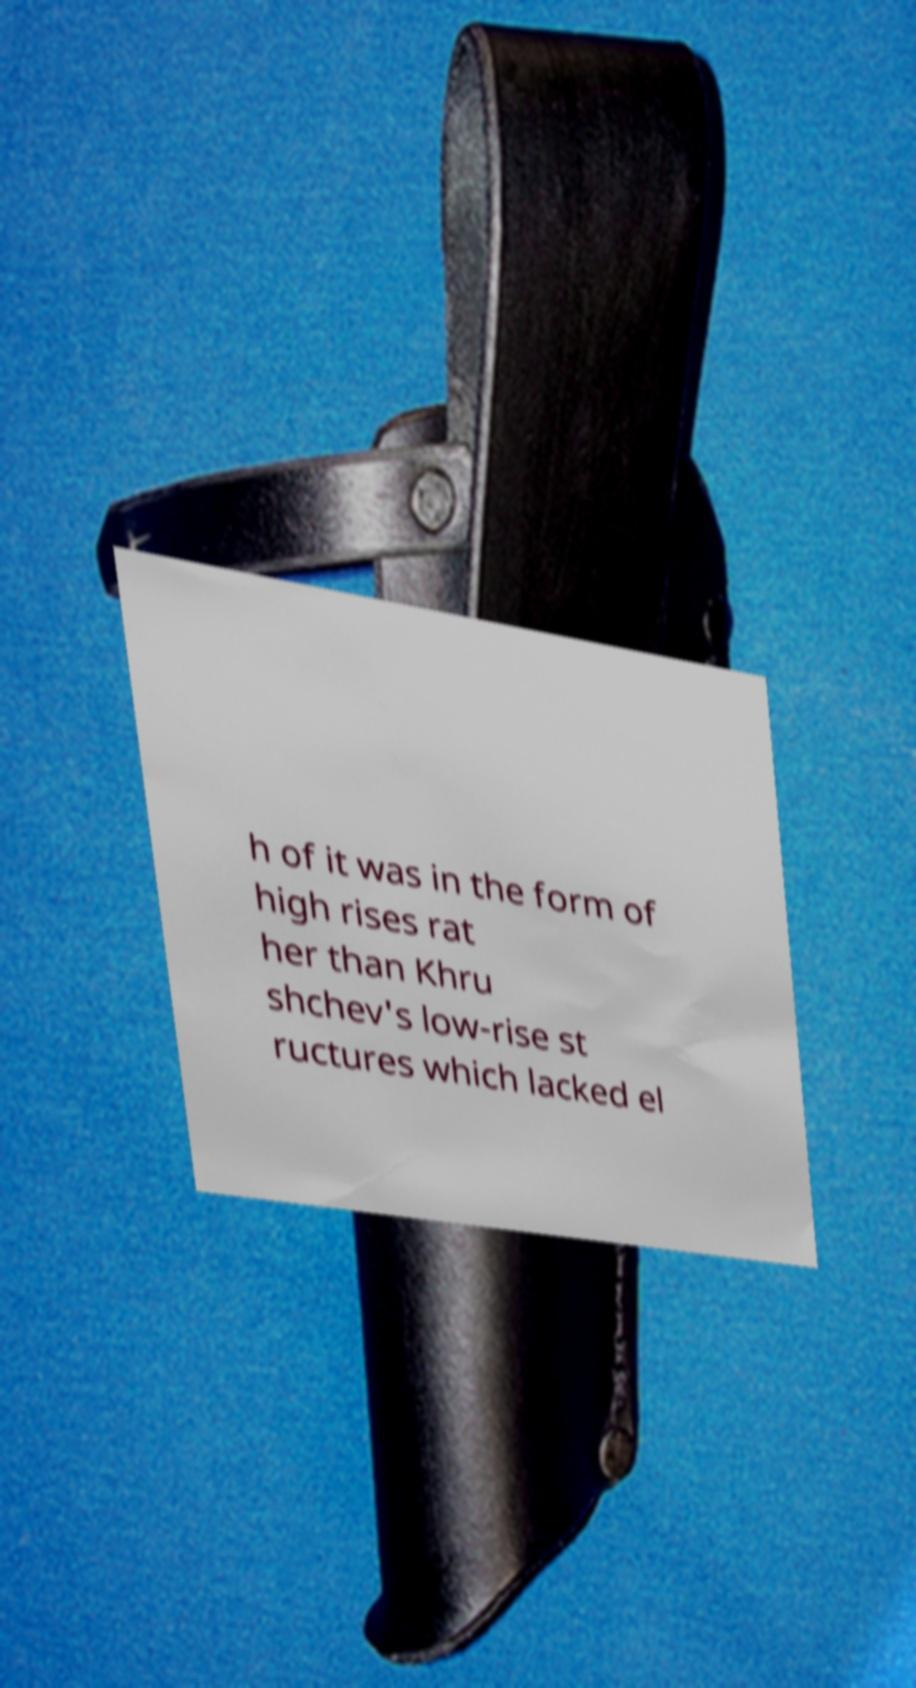I need the written content from this picture converted into text. Can you do that? h of it was in the form of high rises rat her than Khru shchev's low-rise st ructures which lacked el 